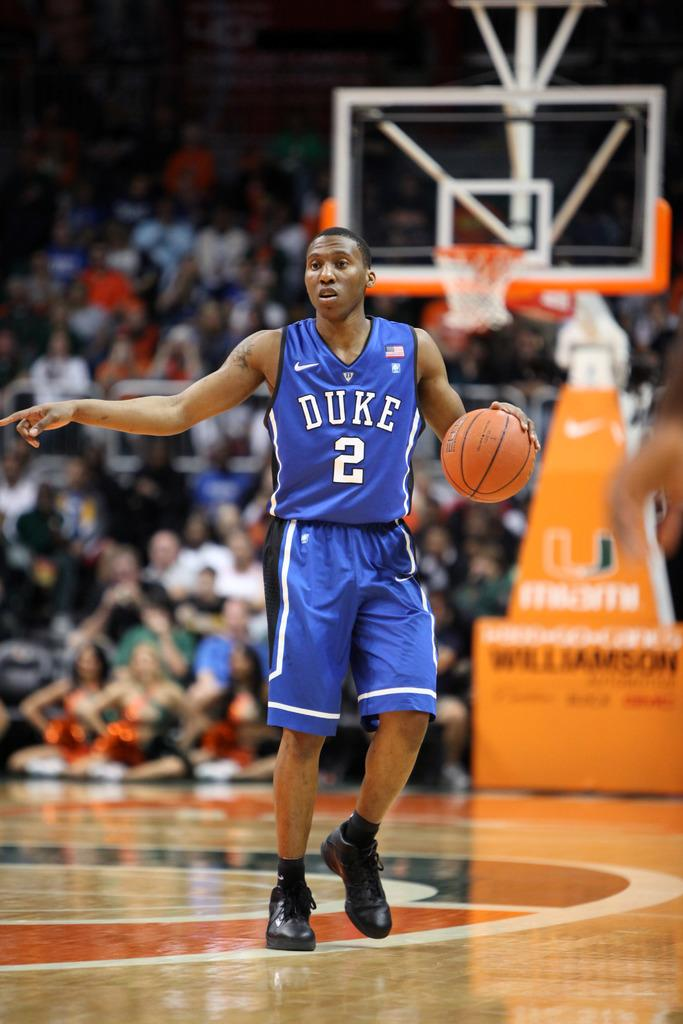How many people are in the image? There is a group of people in the image. What is the man holding in the image? The man is holding a ball in the image. What can be seen in the background of the image? There is a basketball net in the background of the image. What type of insect is crawling on the man's tail in the image? There is no insect or tail present in the image. 